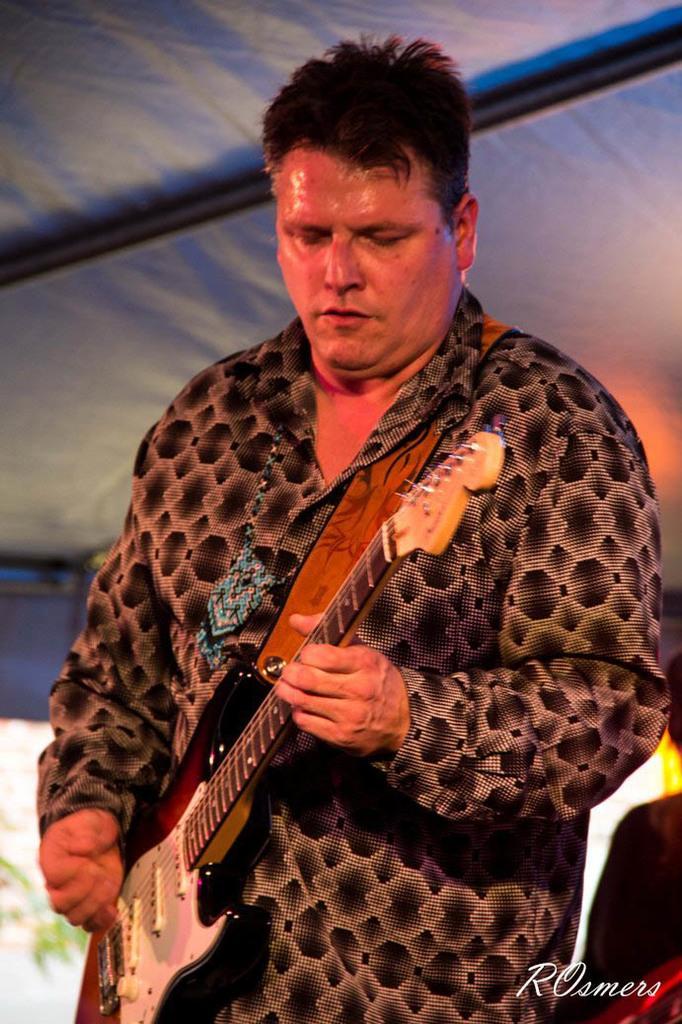Please provide a concise description of this image. In this picture there is a man standing his playing the guitar with his right and he's holding a guitar with his left and is looking at the guitar and the background there is a banner 